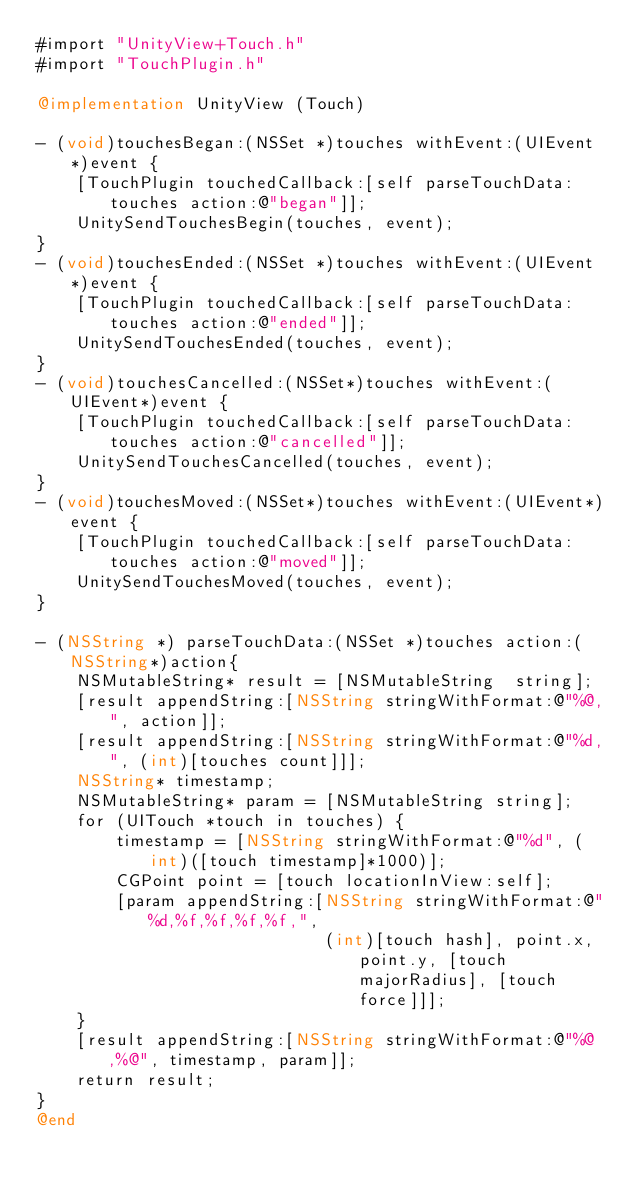Convert code to text. <code><loc_0><loc_0><loc_500><loc_500><_ObjectiveC_>#import "UnityView+Touch.h"
#import "TouchPlugin.h"

@implementation UnityView (Touch)

- (void)touchesBegan:(NSSet *)touches withEvent:(UIEvent *)event {
    [TouchPlugin touchedCallback:[self parseTouchData:touches action:@"began"]];
    UnitySendTouchesBegin(touches, event);
}
- (void)touchesEnded:(NSSet *)touches withEvent:(UIEvent *)event {
    [TouchPlugin touchedCallback:[self parseTouchData:touches action:@"ended"]];
    UnitySendTouchesEnded(touches, event);
}
- (void)touchesCancelled:(NSSet*)touches withEvent:(UIEvent*)event {
    [TouchPlugin touchedCallback:[self parseTouchData:touches action:@"cancelled"]];
    UnitySendTouchesCancelled(touches, event);
}
- (void)touchesMoved:(NSSet*)touches withEvent:(UIEvent*)event {
    [TouchPlugin touchedCallback:[self parseTouchData:touches action:@"moved"]];
    UnitySendTouchesMoved(touches, event);
}

- (NSString *) parseTouchData:(NSSet *)touches action:(NSString*)action{
    NSMutableString* result = [NSMutableString	string];
    [result appendString:[NSString stringWithFormat:@"%@,", action]];
    [result appendString:[NSString stringWithFormat:@"%d,", (int)[touches count]]];
    NSString* timestamp;
    NSMutableString* param = [NSMutableString string];
    for (UITouch *touch in touches) {
        timestamp = [NSString stringWithFormat:@"%d", (int)([touch timestamp]*1000)];
        CGPoint point = [touch locationInView:self];
        [param appendString:[NSString stringWithFormat:@"%d,%f,%f,%f,%f,",
                             (int)[touch hash], point.x, point.y, [touch majorRadius], [touch force]]];
    }
    [result appendString:[NSString stringWithFormat:@"%@,%@", timestamp, param]];
    return result;
}
@end</code> 